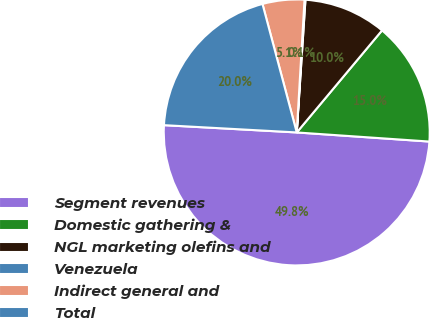Convert chart to OTSL. <chart><loc_0><loc_0><loc_500><loc_500><pie_chart><fcel>Segment revenues<fcel>Domestic gathering &<fcel>NGL marketing olefins and<fcel>Venezuela<fcel>Indirect general and<fcel>Total<nl><fcel>49.78%<fcel>15.01%<fcel>10.04%<fcel>0.11%<fcel>5.08%<fcel>19.98%<nl></chart> 